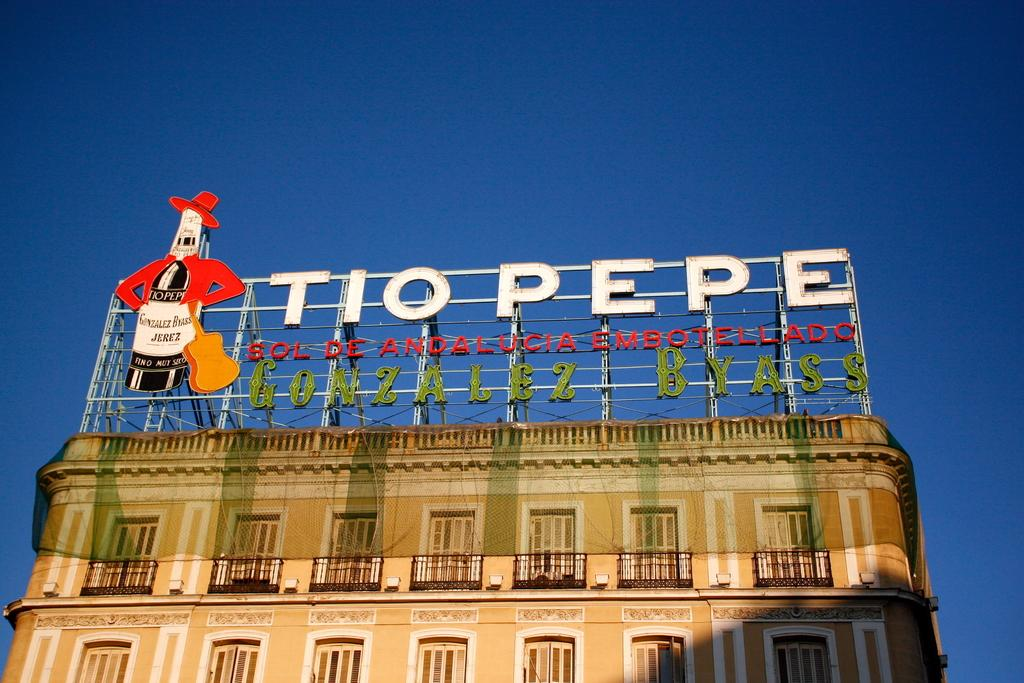What type of structure is present in the image? There is a building in the image. What feature is present on the building? The building has a net. Are there any signs or labels on the building? Yes, the building has name boards. What can be seen in the background of the image? The sky is visible in the background of the image. How many toys are scattered on the ground in the image? There are no toys present in the image. What emotion is displayed by the building in the image? Buildings do not display emotions, so this question cannot be answered. 